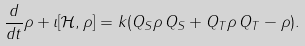<formula> <loc_0><loc_0><loc_500><loc_500>\frac { d } { d t } \rho + \imath [ \mathcal { H } , \rho ] = k ( Q _ { S } \rho \, Q _ { S } + Q _ { T } \rho \, { Q } _ { T } - \rho ) .</formula> 